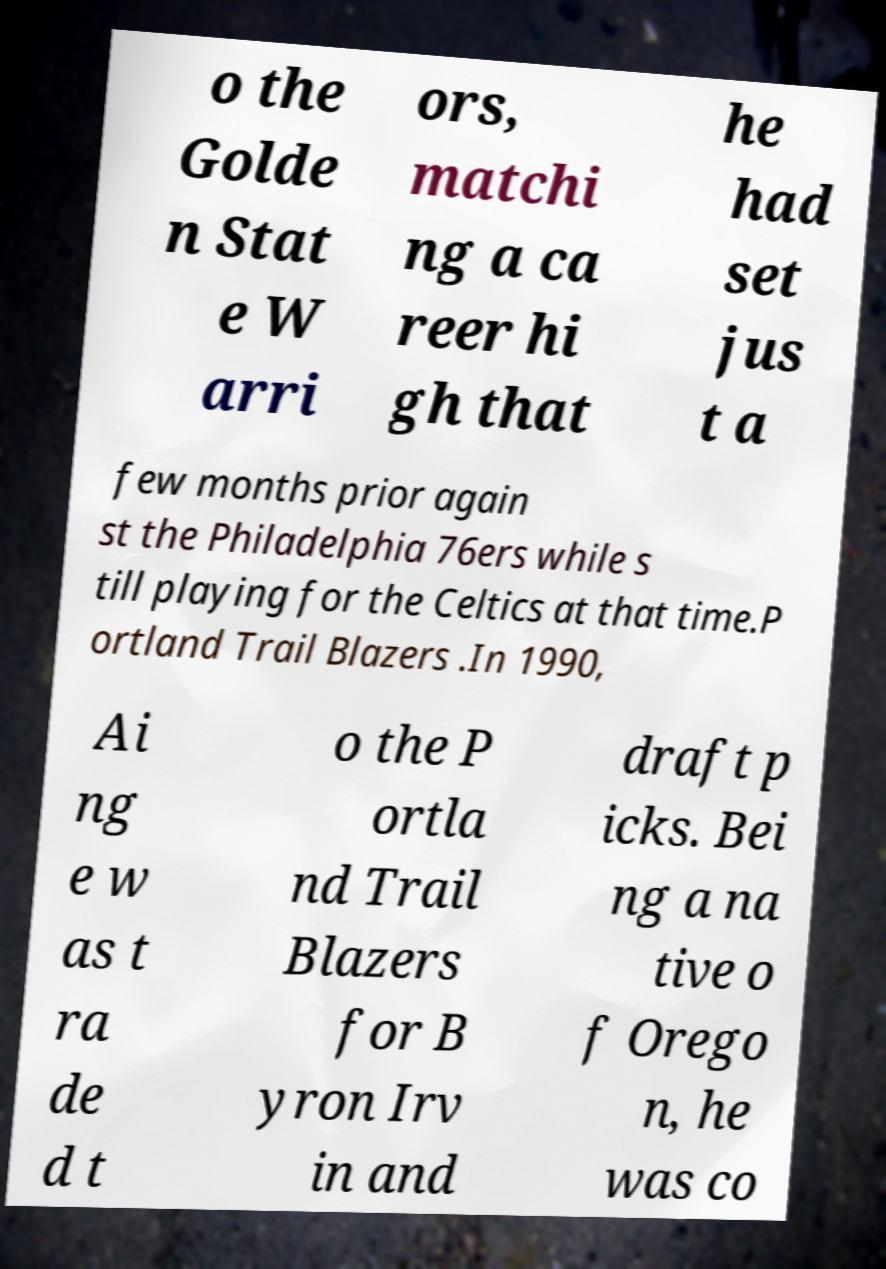Could you assist in decoding the text presented in this image and type it out clearly? o the Golde n Stat e W arri ors, matchi ng a ca reer hi gh that he had set jus t a few months prior again st the Philadelphia 76ers while s till playing for the Celtics at that time.P ortland Trail Blazers .In 1990, Ai ng e w as t ra de d t o the P ortla nd Trail Blazers for B yron Irv in and draft p icks. Bei ng a na tive o f Orego n, he was co 